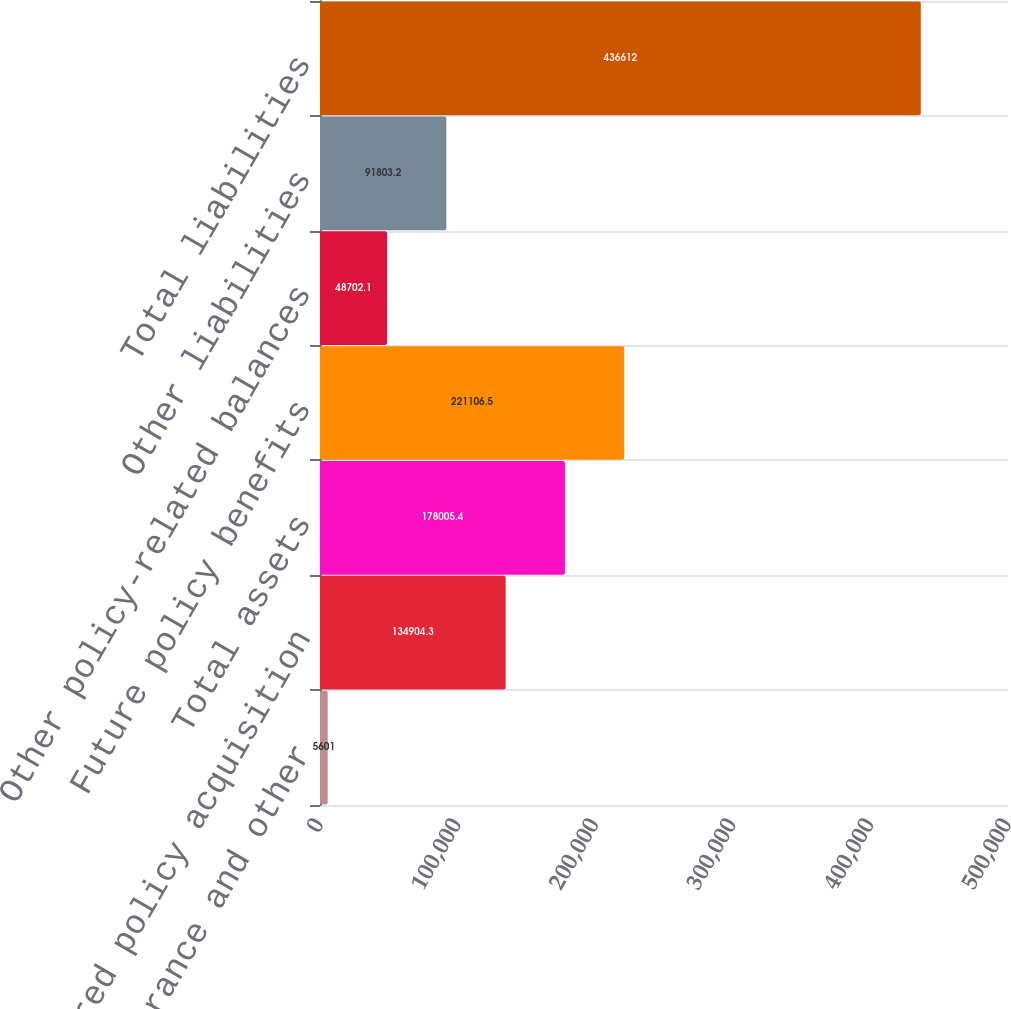Convert chart to OTSL. <chart><loc_0><loc_0><loc_500><loc_500><bar_chart><fcel>Premiums reinsurance and other<fcel>Deferred policy acquisition<fcel>Total assets<fcel>Future policy benefits<fcel>Other policy-related balances<fcel>Other liabilities<fcel>Total liabilities<nl><fcel>5601<fcel>134904<fcel>178005<fcel>221106<fcel>48702.1<fcel>91803.2<fcel>436612<nl></chart> 